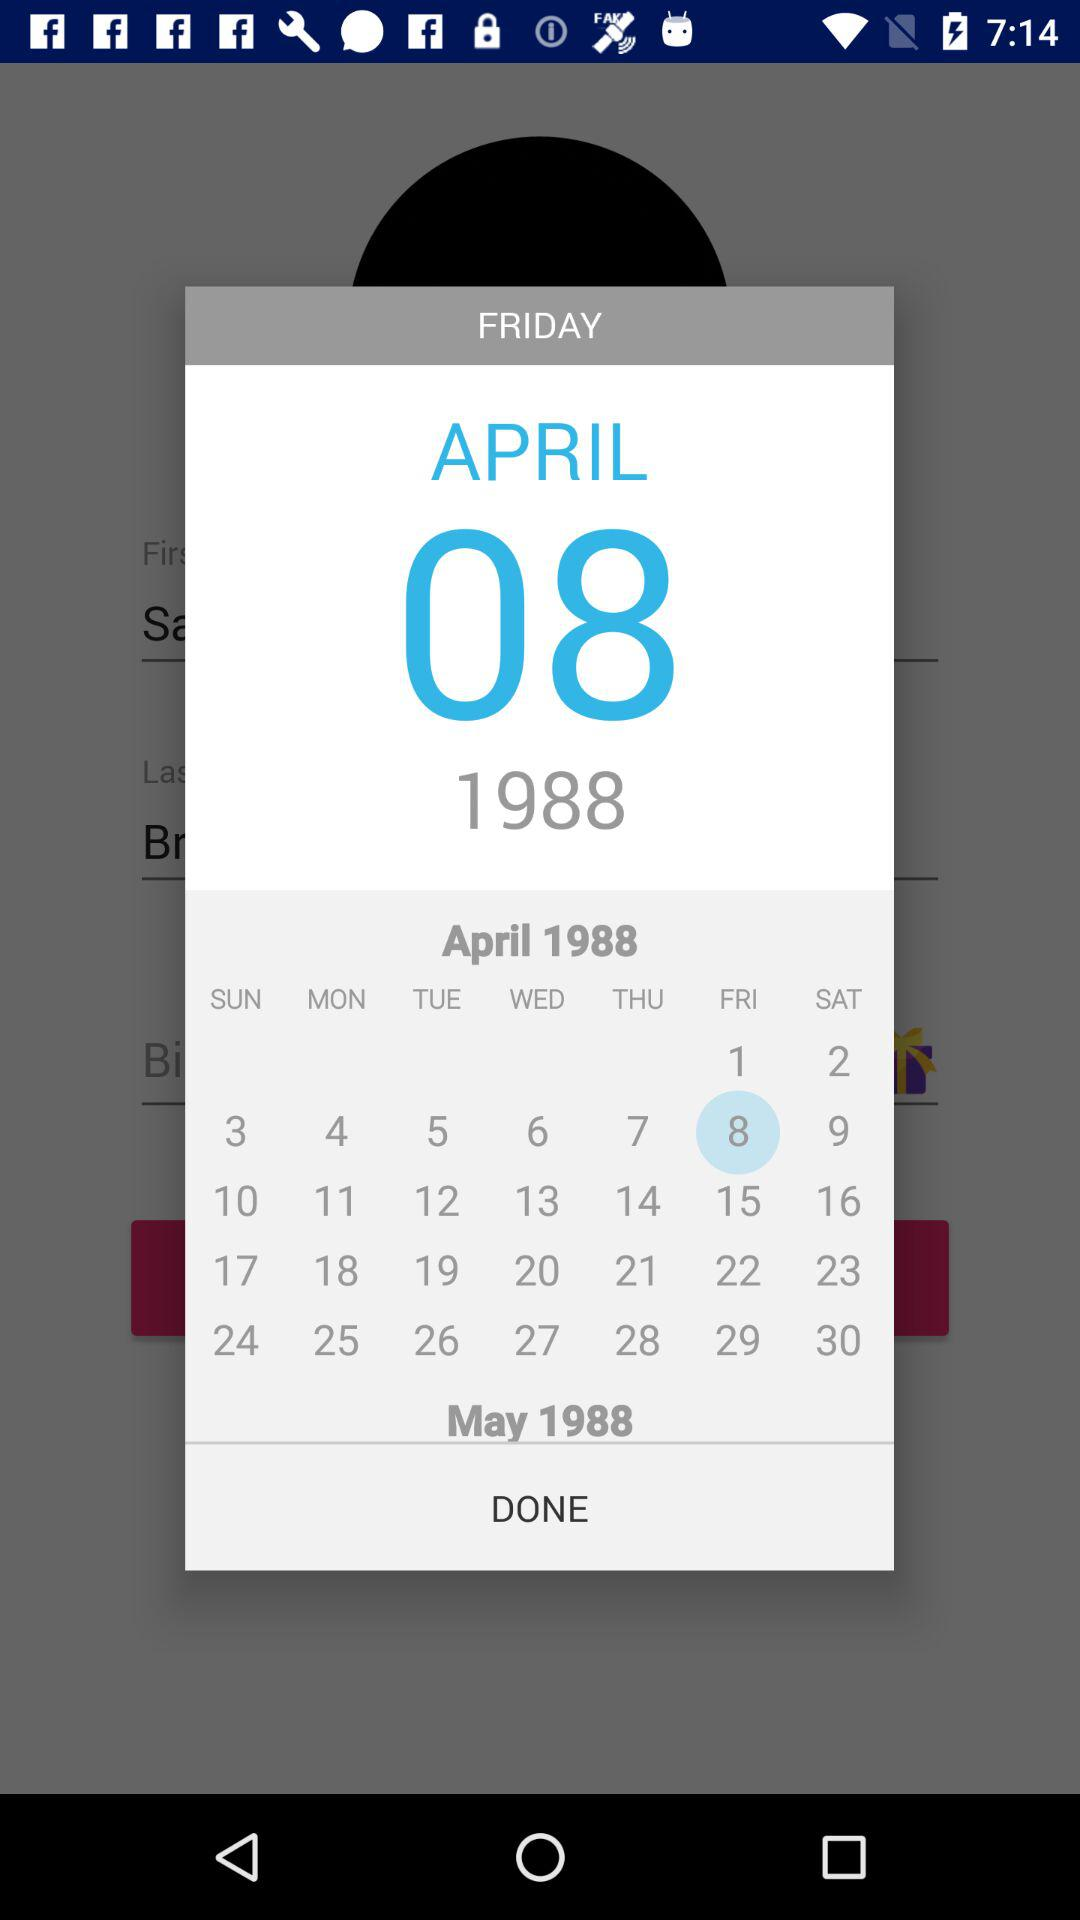What is the selected date? The selected date is Friday, April 8, 1988. 